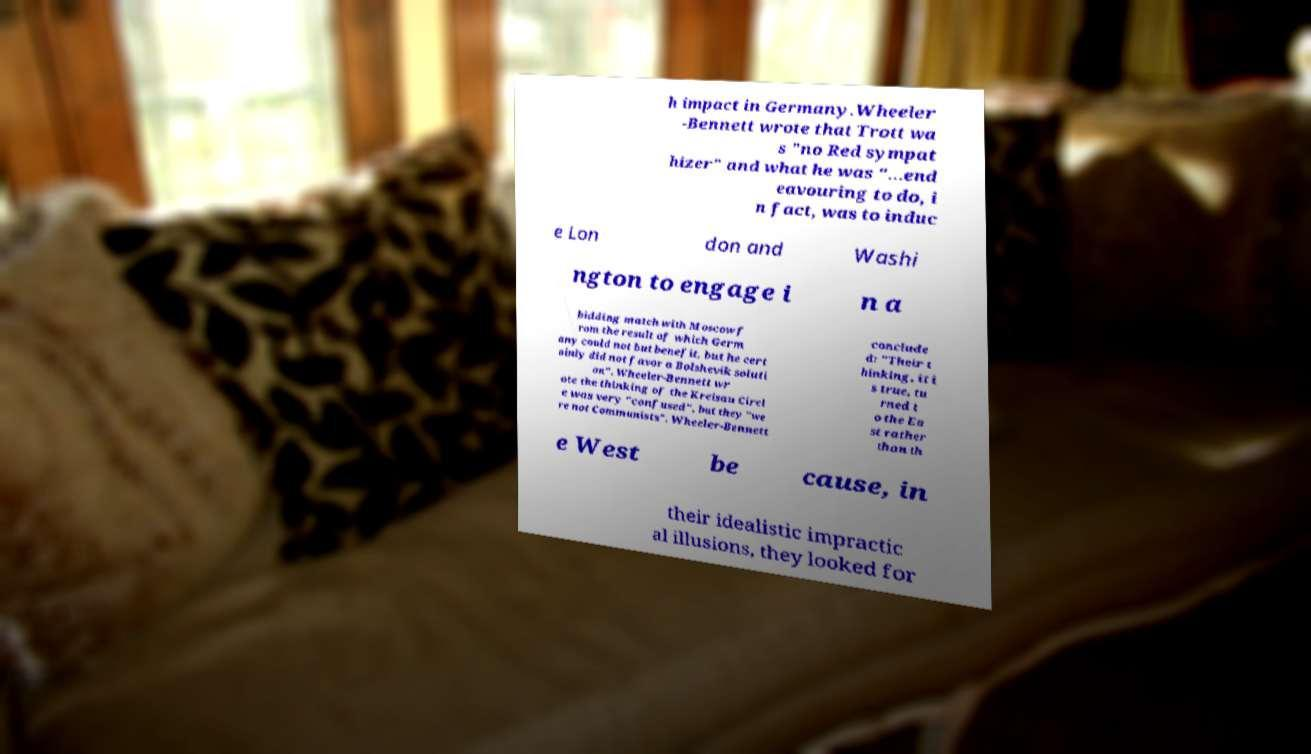Can you read and provide the text displayed in the image?This photo seems to have some interesting text. Can you extract and type it out for me? h impact in Germany.Wheeler -Bennett wrote that Trott wa s "no Red sympat hizer" and what he was "...end eavouring to do, i n fact, was to induc e Lon don and Washi ngton to engage i n a bidding match with Moscow f rom the result of which Germ any could not but benefit, but he cert ainly did not favor a Bolshevik soluti on". Wheeler-Bennett wr ote the thinking of the Kreisau Circl e was very "confused", but they "we re not Communists". Wheeler-Bennett conclude d: "Their t hinking, it i s true, tu rned t o the Ea st rather than th e West be cause, in their idealistic impractic al illusions, they looked for 